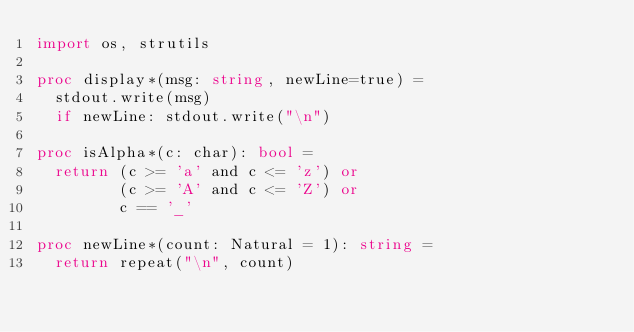Convert code to text. <code><loc_0><loc_0><loc_500><loc_500><_Nim_>import os, strutils

proc display*(msg: string, newLine=true) =
  stdout.write(msg)
  if newLine: stdout.write("\n")

proc isAlpha*(c: char): bool =
  return (c >= 'a' and c <= 'z') or
         (c >= 'A' and c <= 'Z') or
         c == '_'

proc newLine*(count: Natural = 1): string =
  return repeat("\n", count)
</code> 